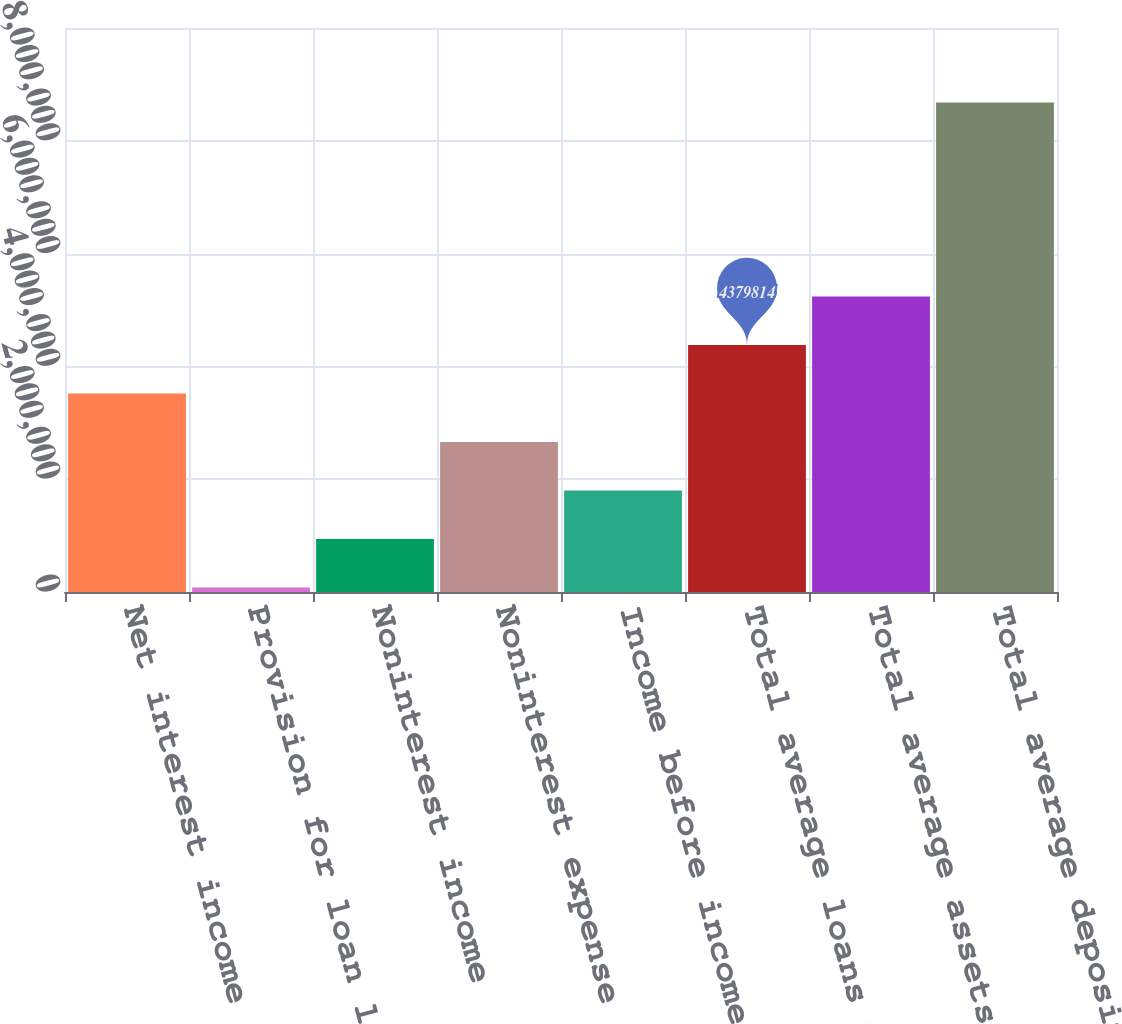<chart> <loc_0><loc_0><loc_500><loc_500><bar_chart><fcel>Net interest income<fcel>Provision for loan losses<fcel>Noninterest income<fcel>Noninterest expense<fcel>Income before income tax<fcel>Total average loans net of<fcel>Total average assets<fcel>Total average deposits<nl><fcel>3.51982e+06<fcel>79867<fcel>939856<fcel>2.65984e+06<fcel>1.79985e+06<fcel>4.37981e+06<fcel>5.2398e+06<fcel>8.67976e+06<nl></chart> 